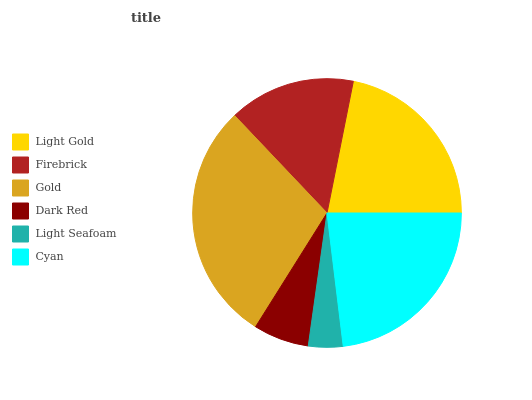Is Light Seafoam the minimum?
Answer yes or no. Yes. Is Gold the maximum?
Answer yes or no. Yes. Is Firebrick the minimum?
Answer yes or no. No. Is Firebrick the maximum?
Answer yes or no. No. Is Light Gold greater than Firebrick?
Answer yes or no. Yes. Is Firebrick less than Light Gold?
Answer yes or no. Yes. Is Firebrick greater than Light Gold?
Answer yes or no. No. Is Light Gold less than Firebrick?
Answer yes or no. No. Is Light Gold the high median?
Answer yes or no. Yes. Is Firebrick the low median?
Answer yes or no. Yes. Is Dark Red the high median?
Answer yes or no. No. Is Cyan the low median?
Answer yes or no. No. 